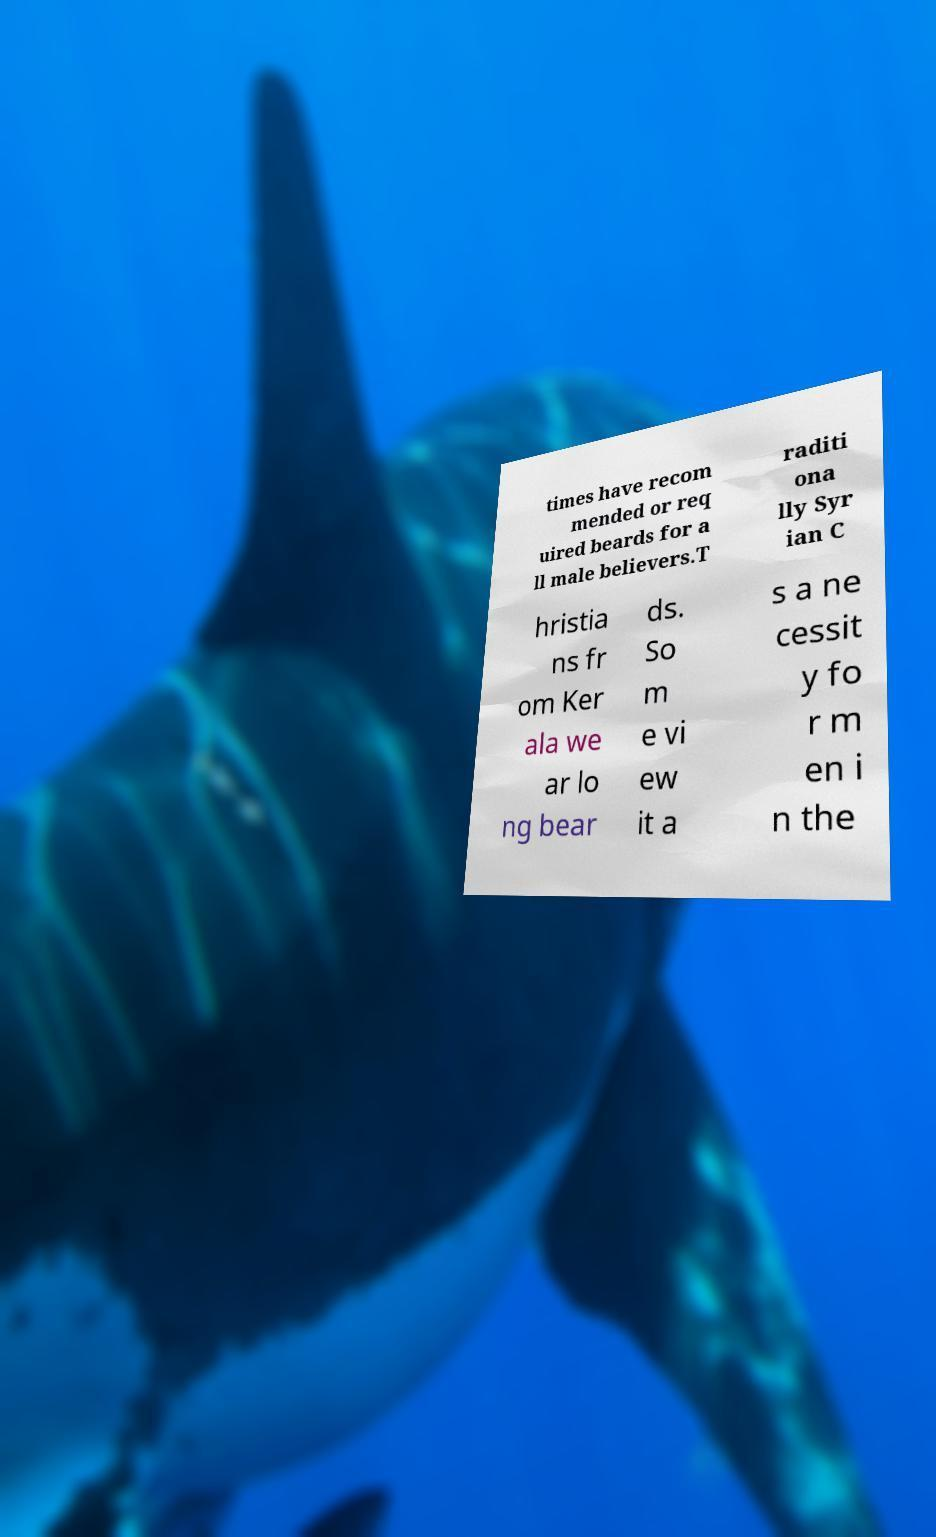I need the written content from this picture converted into text. Can you do that? times have recom mended or req uired beards for a ll male believers.T raditi ona lly Syr ian C hristia ns fr om Ker ala we ar lo ng bear ds. So m e vi ew it a s a ne cessit y fo r m en i n the 